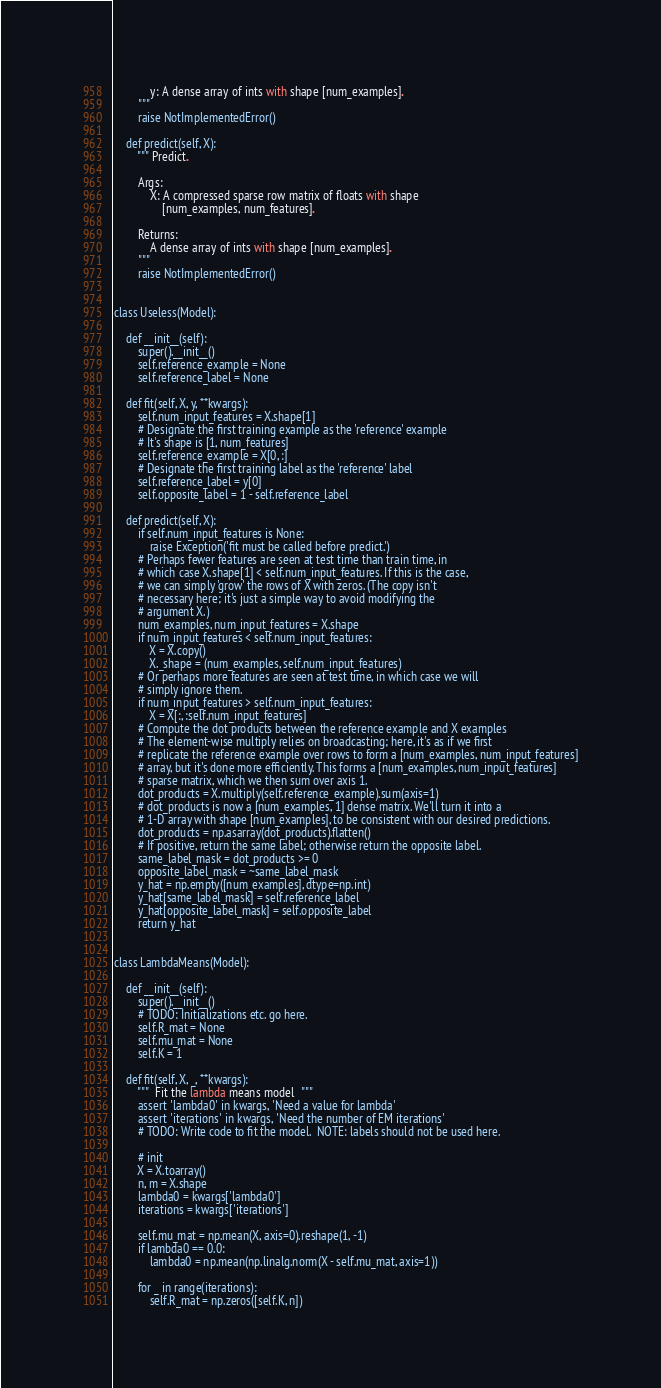Convert code to text. <code><loc_0><loc_0><loc_500><loc_500><_Python_>            y: A dense array of ints with shape [num_examples].
        """
        raise NotImplementedError()

    def predict(self, X):
        """ Predict.

        Args:
            X: A compressed sparse row matrix of floats with shape
                [num_examples, num_features].

        Returns:
            A dense array of ints with shape [num_examples].
        """
        raise NotImplementedError()


class Useless(Model):

    def __init__(self):
        super().__init__()
        self.reference_example = None
        self.reference_label = None

    def fit(self, X, y, **kwargs):
        self.num_input_features = X.shape[1]
        # Designate the first training example as the 'reference' example
        # It's shape is [1, num_features]
        self.reference_example = X[0, :]
        # Designate the first training label as the 'reference' label
        self.reference_label = y[0]
        self.opposite_label = 1 - self.reference_label

    def predict(self, X):
        if self.num_input_features is None:
            raise Exception('fit must be called before predict.')
        # Perhaps fewer features are seen at test time than train time, in
        # which case X.shape[1] < self.num_input_features. If this is the case,
        # we can simply 'grow' the rows of X with zeros. (The copy isn't
        # necessary here; it's just a simple way to avoid modifying the
        # argument X.)
        num_examples, num_input_features = X.shape
        if num_input_features < self.num_input_features:
            X = X.copy()
            X._shape = (num_examples, self.num_input_features)
        # Or perhaps more features are seen at test time, in which case we will
        # simply ignore them.
        if num_input_features > self.num_input_features:
            X = X[:, :self.num_input_features]
        # Compute the dot products between the reference example and X examples
        # The element-wise multiply relies on broadcasting; here, it's as if we first
        # replicate the reference example over rows to form a [num_examples, num_input_features]
        # array, but it's done more efficiently. This forms a [num_examples, num_input_features]
        # sparse matrix, which we then sum over axis 1.
        dot_products = X.multiply(self.reference_example).sum(axis=1)
        # dot_products is now a [num_examples, 1] dense matrix. We'll turn it into a
        # 1-D array with shape [num_examples], to be consistent with our desired predictions.
        dot_products = np.asarray(dot_products).flatten()
        # If positive, return the same label; otherwise return the opposite label.
        same_label_mask = dot_products >= 0
        opposite_label_mask = ~same_label_mask
        y_hat = np.empty([num_examples], dtype=np.int)
        y_hat[same_label_mask] = self.reference_label
        y_hat[opposite_label_mask] = self.opposite_label
        return y_hat


class LambdaMeans(Model):

    def __init__(self):
        super().__init__()
        # TODO: Initializations etc. go here.
        self.R_mat = None
        self.mu_mat = None
        self.K = 1

    def fit(self, X, _, **kwargs):
        """  Fit the lambda means model  """
        assert 'lambda0' in kwargs, 'Need a value for lambda'
        assert 'iterations' in kwargs, 'Need the number of EM iterations'
        # TODO: Write code to fit the model.  NOTE: labels should not be used here.

        # init
        X = X.toarray()
        n, m = X.shape
        lambda0 = kwargs['lambda0']
        iterations = kwargs['iterations']

        self.mu_mat = np.mean(X, axis=0).reshape(1, -1)
        if lambda0 == 0.0:
            lambda0 = np.mean(np.linalg.norm(X - self.mu_mat, axis=1))

        for _ in range(iterations):
            self.R_mat = np.zeros([self.K, n])</code> 